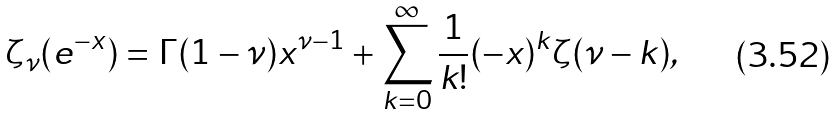Convert formula to latex. <formula><loc_0><loc_0><loc_500><loc_500>\zeta _ { \nu } ( e ^ { - x } ) = \Gamma ( 1 - \nu ) x ^ { \nu - 1 } + \sum _ { k = 0 } ^ { \infty } \frac { 1 } { k ! } ( - x ) ^ { k } \zeta ( \nu - k ) ,</formula> 